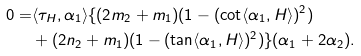<formula> <loc_0><loc_0><loc_500><loc_500>0 = & \langle \tau _ { H } , \alpha _ { 1 } \rangle \{ ( 2 m _ { 2 } + m _ { 1 } ) ( 1 - ( \cot \langle \alpha _ { 1 } , H \rangle ) ^ { 2 } ) \\ & + ( 2 n _ { 2 } + m _ { 1 } ) ( 1 - ( \tan \langle \alpha _ { 1 } , H \rangle ) ^ { 2 } ) \} ( \alpha _ { 1 } + 2 \alpha _ { 2 } ) .</formula> 